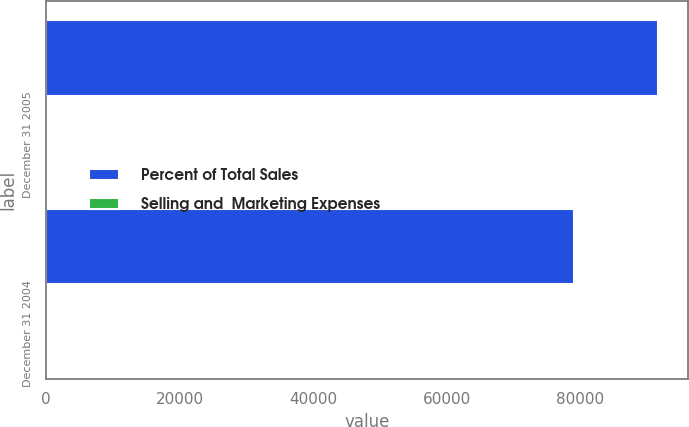<chart> <loc_0><loc_0><loc_500><loc_500><stacked_bar_chart><ecel><fcel>December 31 2005<fcel>December 31 2004<nl><fcel>Percent of Total Sales<fcel>91630<fcel>79111<nl><fcel>Selling and  Marketing Expenses<fcel>13<fcel>11.9<nl></chart> 